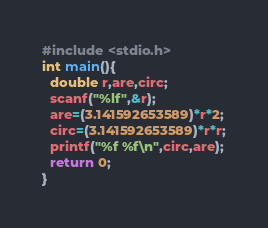<code> <loc_0><loc_0><loc_500><loc_500><_C_>#include <stdio.h>
int main(){
  double r,are,circ;
  scanf("%lf",&r);
  are=(3.141592653589)*r*2;
  circ=(3.141592653589)*r*r;
  printf("%f %f\n",circ,are);
  return 0;
}</code> 